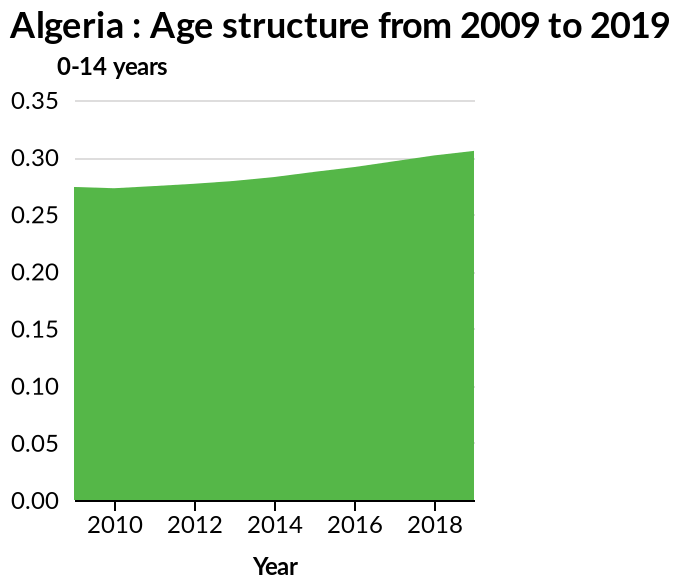<image>
What is the range of years represented on the x-axis of the plot?  The range of years represented on the x-axis of the plot is from 2010 to 2018. What has been happening to the number of people aged 0-14 from 2010-2018?  The number of people aged 0-14 has been steadily growing from 2010-2018. What age group is depicted on the y-axis of the plot?  The age group depicted on the y-axis of the plot is 0-14 years. 